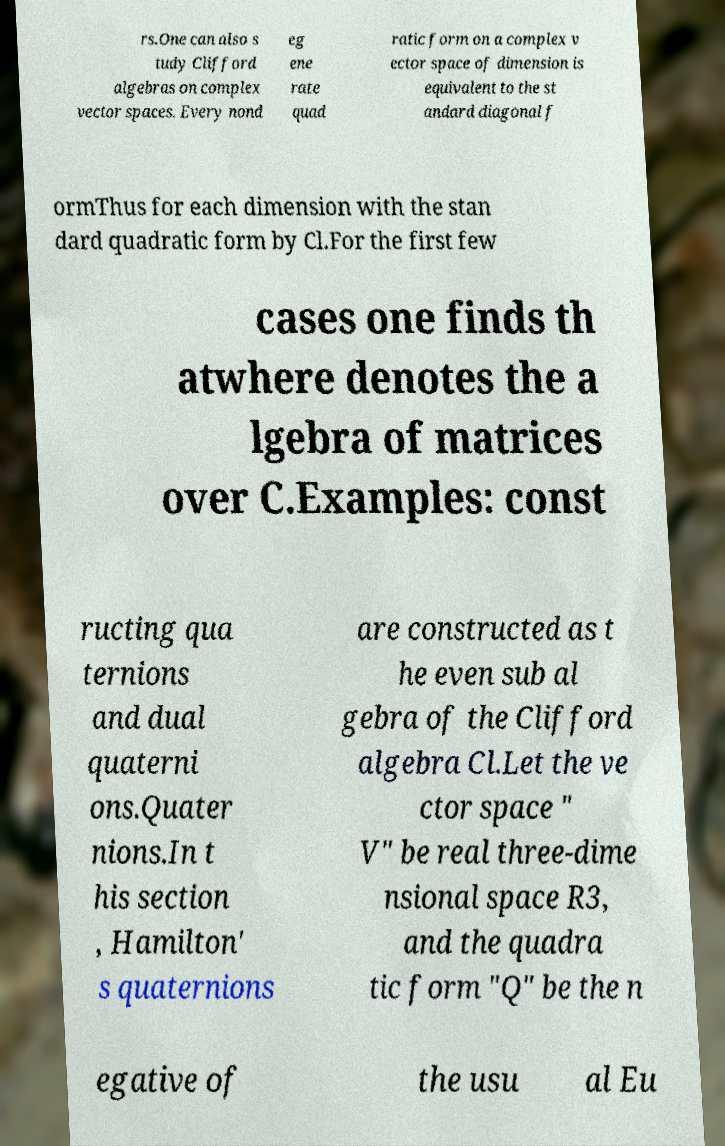For documentation purposes, I need the text within this image transcribed. Could you provide that? rs.One can also s tudy Clifford algebras on complex vector spaces. Every nond eg ene rate quad ratic form on a complex v ector space of dimension is equivalent to the st andard diagonal f ormThus for each dimension with the stan dard quadratic form by Cl.For the first few cases one finds th atwhere denotes the a lgebra of matrices over C.Examples: const ructing qua ternions and dual quaterni ons.Quater nions.In t his section , Hamilton' s quaternions are constructed as t he even sub al gebra of the Clifford algebra Cl.Let the ve ctor space " V" be real three-dime nsional space R3, and the quadra tic form "Q" be the n egative of the usu al Eu 